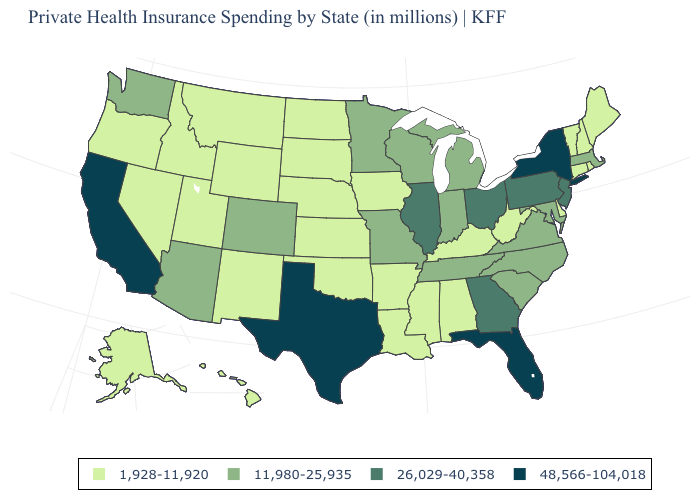What is the lowest value in the MidWest?
Keep it brief. 1,928-11,920. How many symbols are there in the legend?
Be succinct. 4. Which states have the lowest value in the West?
Keep it brief. Alaska, Hawaii, Idaho, Montana, Nevada, New Mexico, Oregon, Utah, Wyoming. Name the states that have a value in the range 48,566-104,018?
Give a very brief answer. California, Florida, New York, Texas. What is the highest value in the USA?
Be succinct. 48,566-104,018. Among the states that border Delaware , does Pennsylvania have the lowest value?
Keep it brief. No. Does Colorado have a higher value than Alaska?
Be succinct. Yes. Is the legend a continuous bar?
Write a very short answer. No. What is the value of Maryland?
Give a very brief answer. 11,980-25,935. Does the first symbol in the legend represent the smallest category?
Quick response, please. Yes. Name the states that have a value in the range 26,029-40,358?
Keep it brief. Georgia, Illinois, New Jersey, Ohio, Pennsylvania. Does Texas have the lowest value in the USA?
Be succinct. No. Which states have the lowest value in the USA?
Keep it brief. Alabama, Alaska, Arkansas, Connecticut, Delaware, Hawaii, Idaho, Iowa, Kansas, Kentucky, Louisiana, Maine, Mississippi, Montana, Nebraska, Nevada, New Hampshire, New Mexico, North Dakota, Oklahoma, Oregon, Rhode Island, South Dakota, Utah, Vermont, West Virginia, Wyoming. Among the states that border South Carolina , does North Carolina have the highest value?
Short answer required. No. What is the lowest value in states that border Ohio?
Keep it brief. 1,928-11,920. 